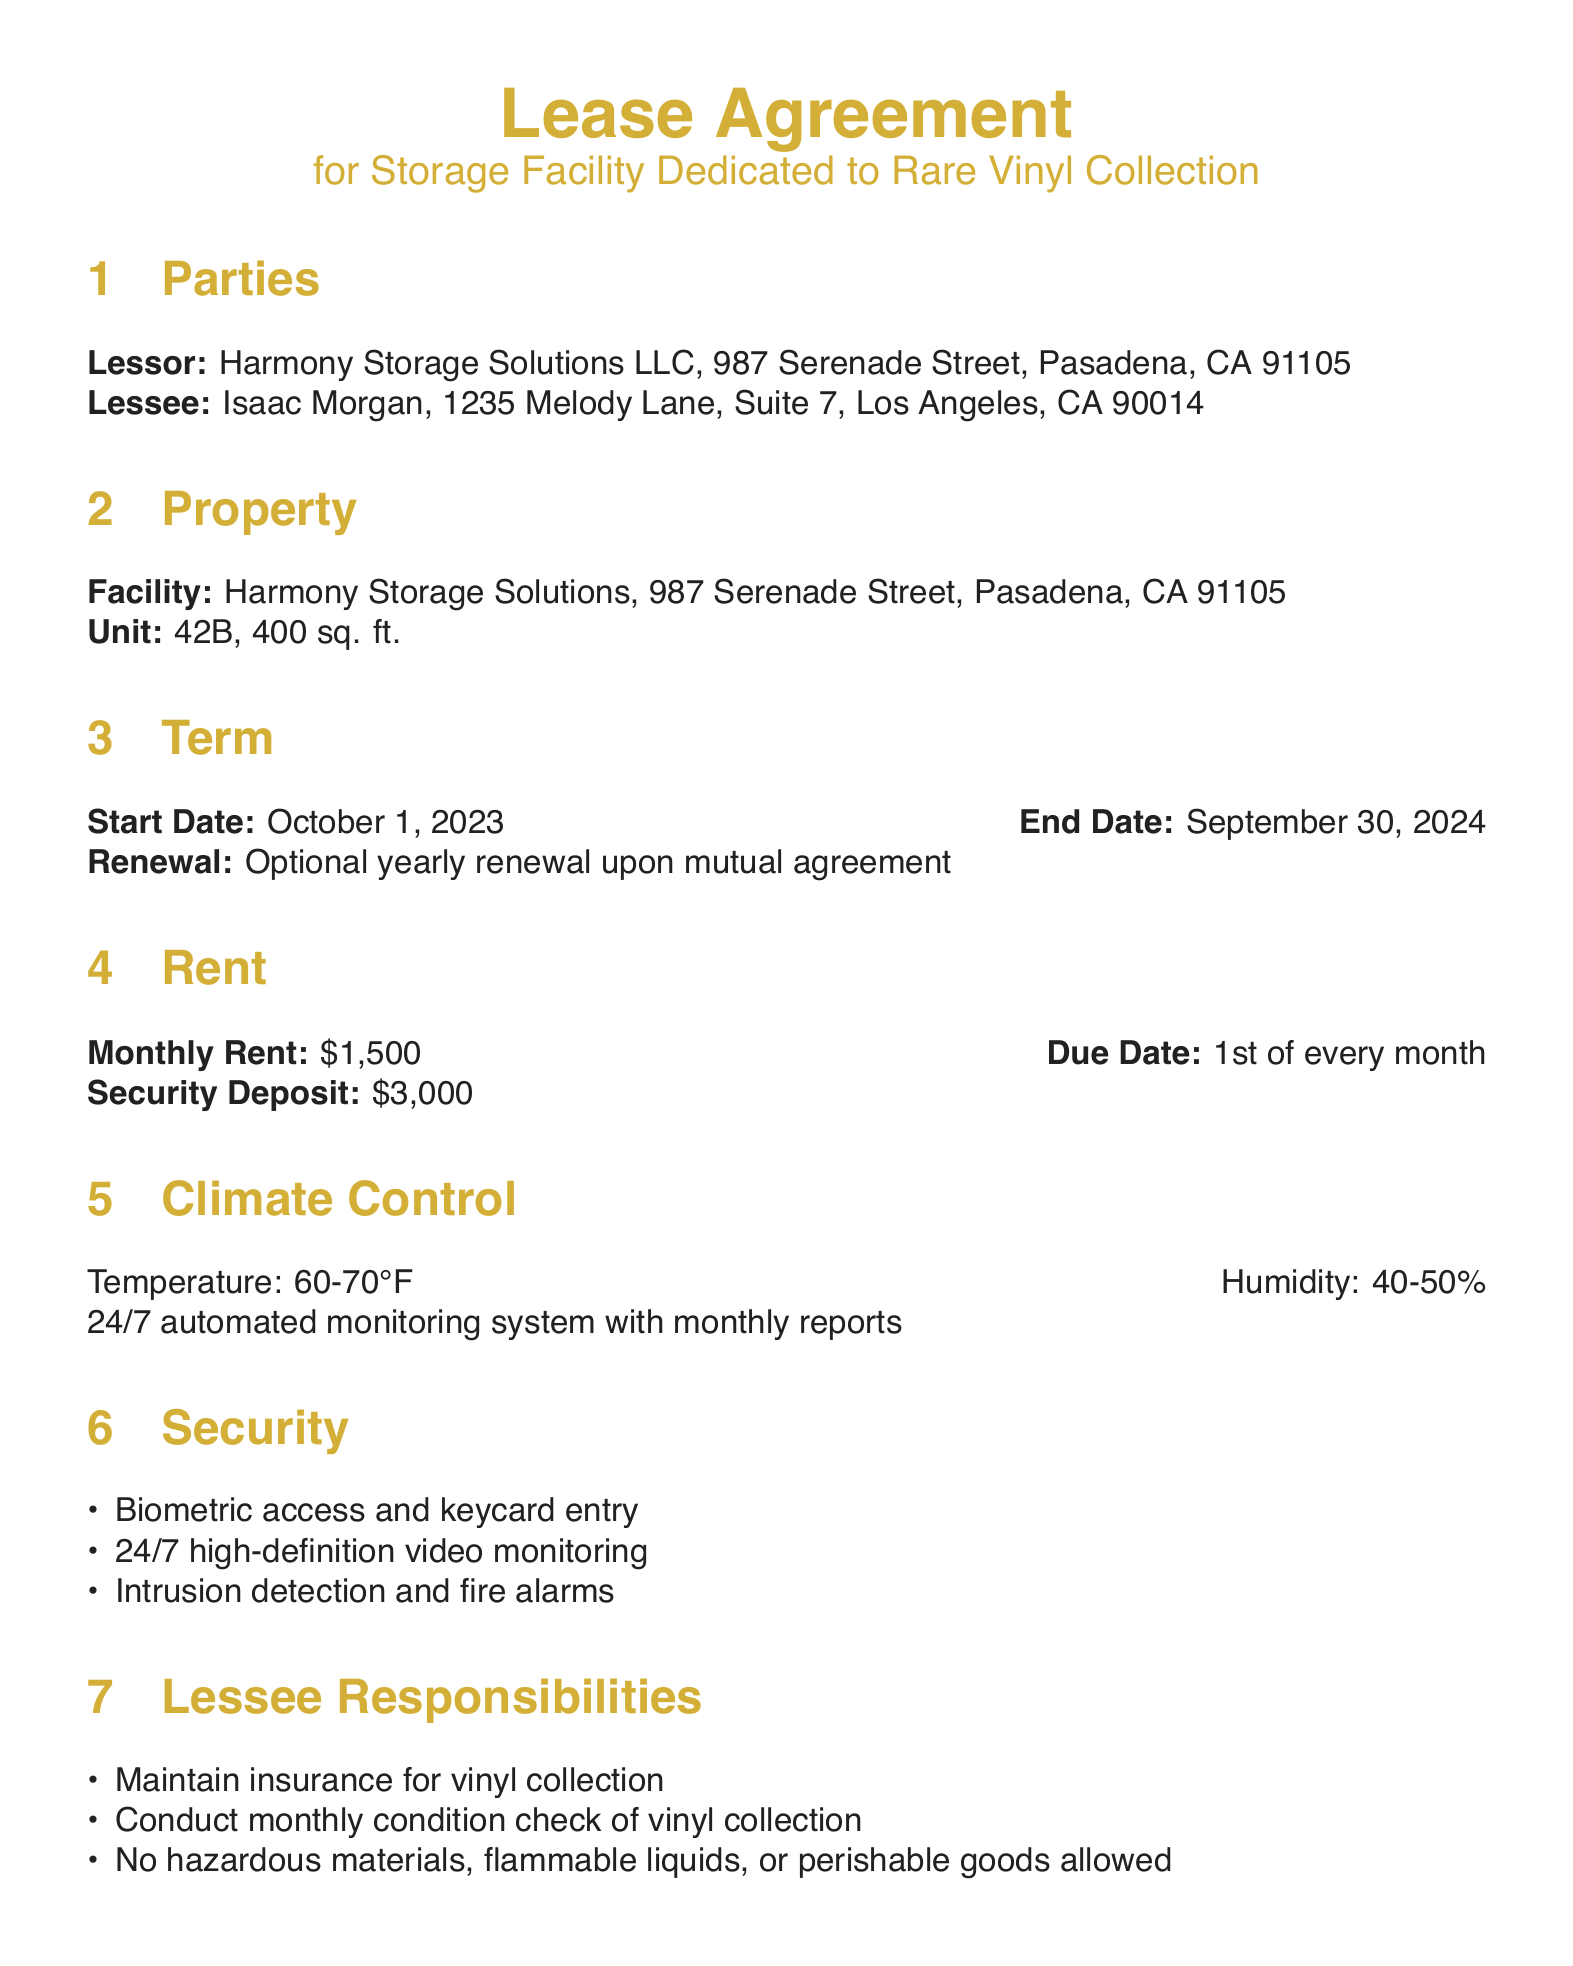What is the name of the Lessor? The Lessor is identified as Harmony Storage Solutions LLC in the document.
Answer: Harmony Storage Solutions LLC What is the monthly rent amount? The document states the monthly rent is $1,500.
Answer: $1,500 What is the term duration for the lease? The lease duration starts on October 1, 2023, and ends on September 30, 2024, which is one year.
Answer: One year What security measures are mentioned? The document lists biometric access, keycard entry, high-definition video monitoring, intrusion detection, and fire alarms as security measures.
Answer: Biometric access, keycard entry, high-definition video monitoring, intrusion detection, fire alarms What is the required humidity level for climate control? The document specifies that the humidity level must be between 40-50%.
Answer: 40-50% What is Isaac Morgan's responsibility concerning the vinyl collection? The document states that Isaac Morgan must maintain insurance for the vinyl collection.
Answer: Maintain insurance When is the rent due each month? According to the lease agreement, the rent is due on the 1st of every month.
Answer: 1st of every month How much is the security deposit? The document specifies that the security deposit is $3,000.
Answer: $3,000 Is there an option for renewal of the lease? The lease agreement states that there is an optional yearly renewal upon mutual agreement.
Answer: Optional yearly renewal What temperature range is required for the climate control? The document states the temperature range must be maintained between 60-70°F.
Answer: 60-70°F 